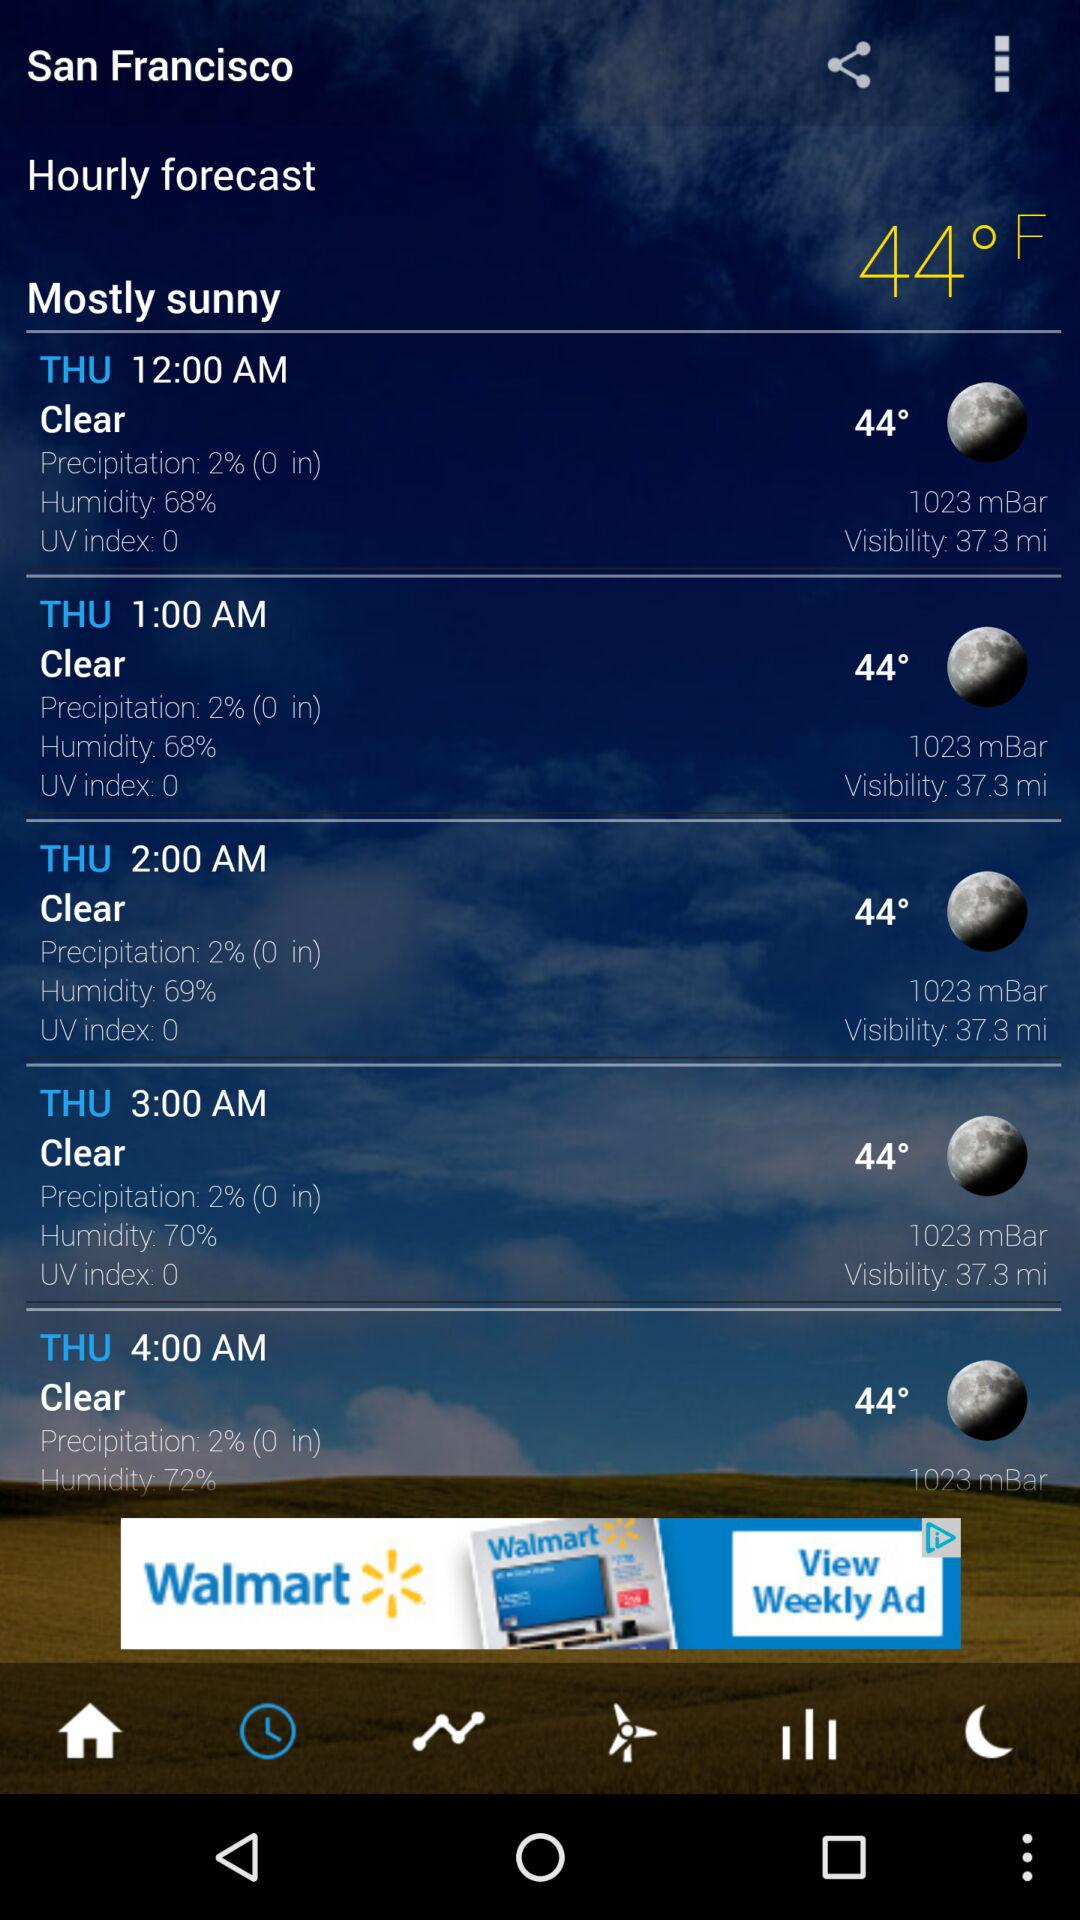What is the humidity percentage at 1:00 AM? The humidity percentage is 68. 